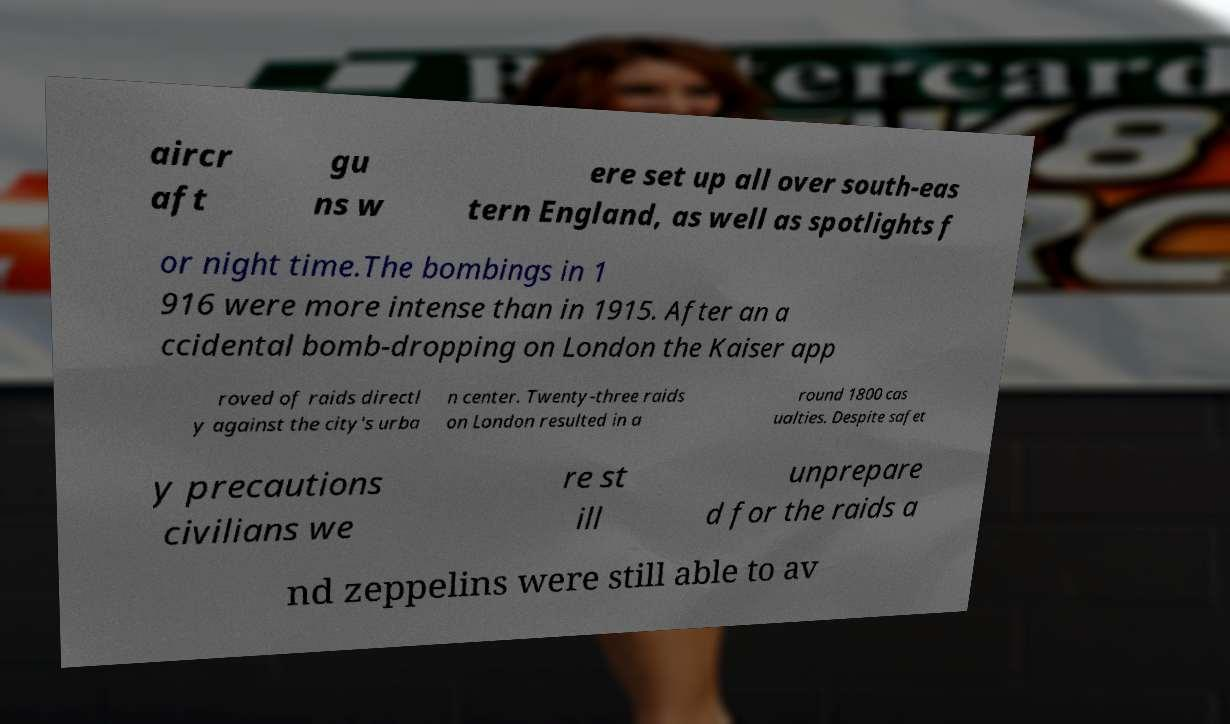Please identify and transcribe the text found in this image. aircr aft gu ns w ere set up all over south-eas tern England, as well as spotlights f or night time.The bombings in 1 916 were more intense than in 1915. After an a ccidental bomb-dropping on London the Kaiser app roved of raids directl y against the city's urba n center. Twenty-three raids on London resulted in a round 1800 cas ualties. Despite safet y precautions civilians we re st ill unprepare d for the raids a nd zeppelins were still able to av 